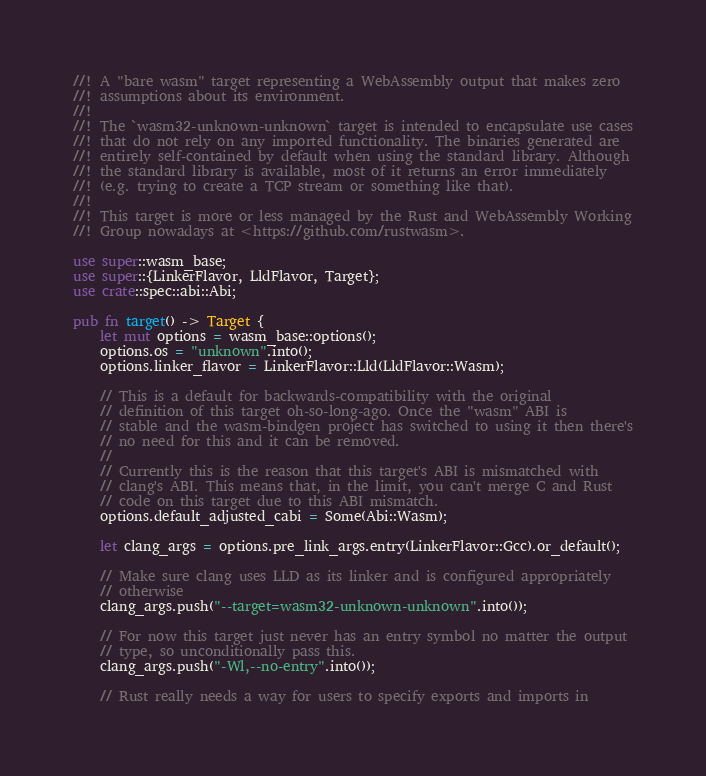<code> <loc_0><loc_0><loc_500><loc_500><_Rust_>//! A "bare wasm" target representing a WebAssembly output that makes zero
//! assumptions about its environment.
//!
//! The `wasm32-unknown-unknown` target is intended to encapsulate use cases
//! that do not rely on any imported functionality. The binaries generated are
//! entirely self-contained by default when using the standard library. Although
//! the standard library is available, most of it returns an error immediately
//! (e.g. trying to create a TCP stream or something like that).
//!
//! This target is more or less managed by the Rust and WebAssembly Working
//! Group nowadays at <https://github.com/rustwasm>.

use super::wasm_base;
use super::{LinkerFlavor, LldFlavor, Target};
use crate::spec::abi::Abi;

pub fn target() -> Target {
    let mut options = wasm_base::options();
    options.os = "unknown".into();
    options.linker_flavor = LinkerFlavor::Lld(LldFlavor::Wasm);

    // This is a default for backwards-compatibility with the original
    // definition of this target oh-so-long-ago. Once the "wasm" ABI is
    // stable and the wasm-bindgen project has switched to using it then there's
    // no need for this and it can be removed.
    //
    // Currently this is the reason that this target's ABI is mismatched with
    // clang's ABI. This means that, in the limit, you can't merge C and Rust
    // code on this target due to this ABI mismatch.
    options.default_adjusted_cabi = Some(Abi::Wasm);

    let clang_args = options.pre_link_args.entry(LinkerFlavor::Gcc).or_default();

    // Make sure clang uses LLD as its linker and is configured appropriately
    // otherwise
    clang_args.push("--target=wasm32-unknown-unknown".into());

    // For now this target just never has an entry symbol no matter the output
    // type, so unconditionally pass this.
    clang_args.push("-Wl,--no-entry".into());

    // Rust really needs a way for users to specify exports and imports in</code> 